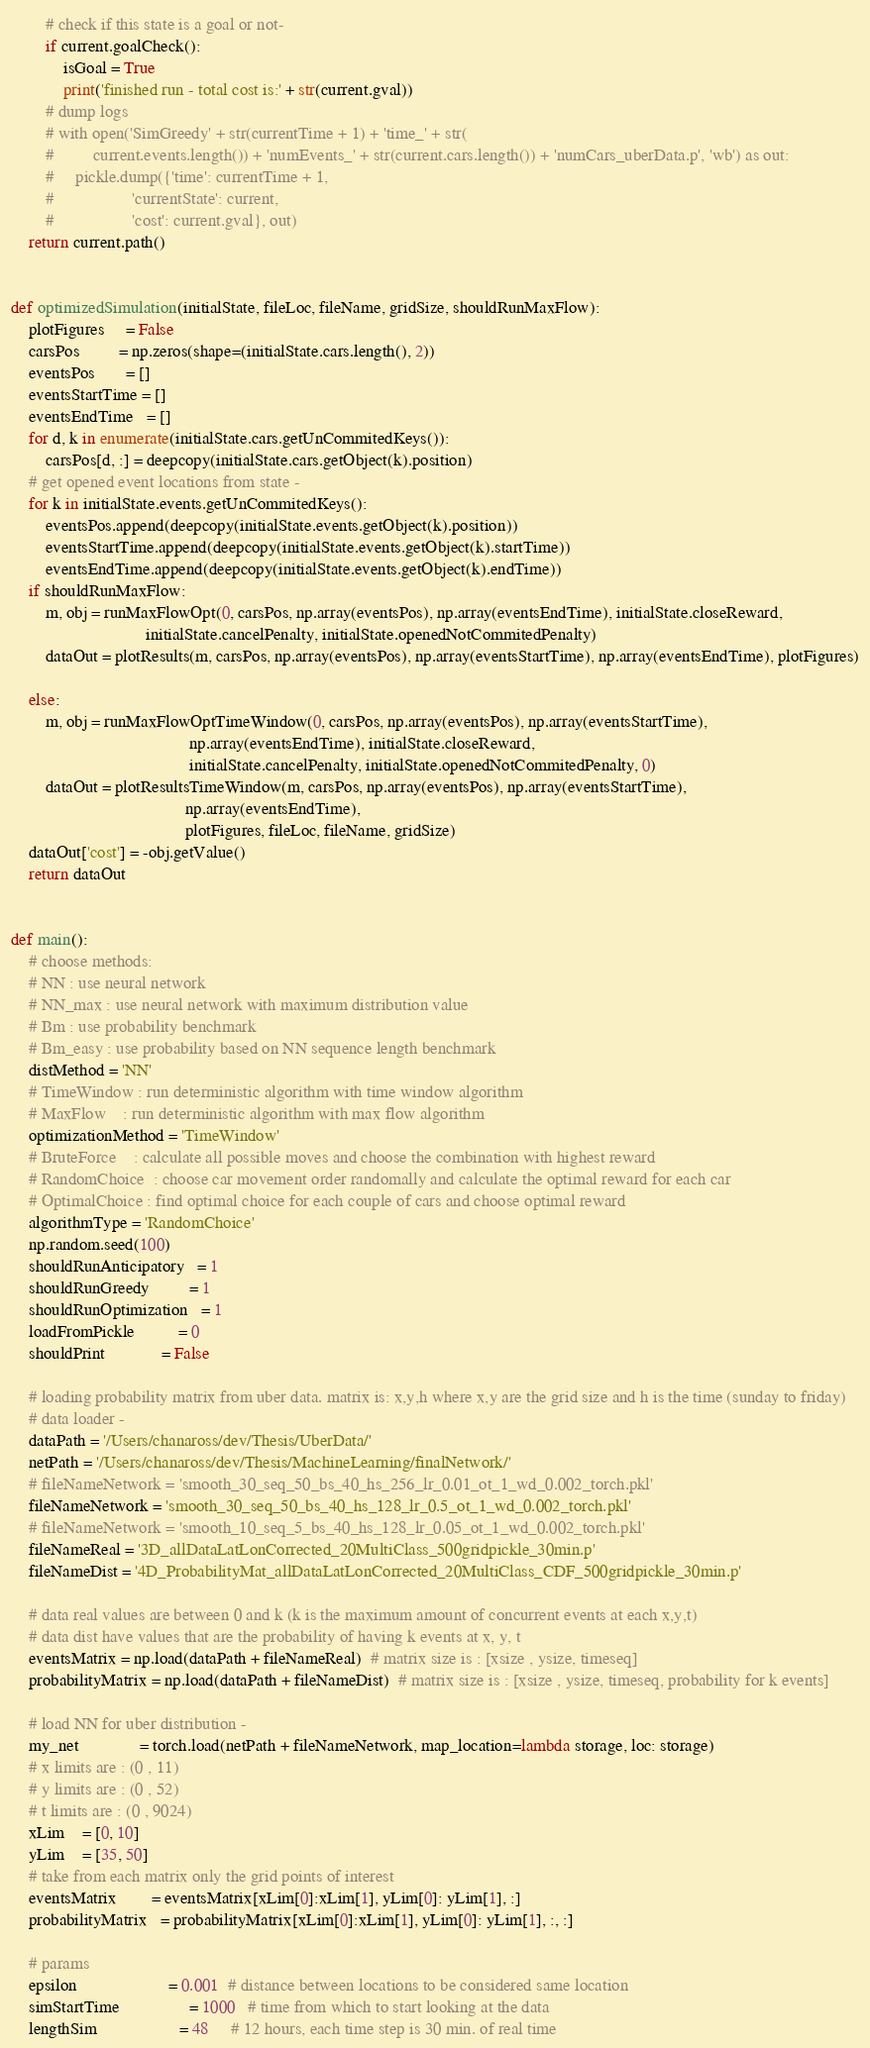Convert code to text. <code><loc_0><loc_0><loc_500><loc_500><_Python_>        # check if this state is a goal or not-
        if current.goalCheck():
            isGoal = True
            print('finished run - total cost is:' + str(current.gval))
        # dump logs
        # with open('SimGreedy' + str(currentTime + 1) + 'time_' + str(
        #         current.events.length()) + 'numEvents_' + str(current.cars.length()) + 'numCars_uberData.p', 'wb') as out:
        #     pickle.dump({'time': currentTime + 1,
        #                  'currentState': current,
        #                  'cost': current.gval}, out)
    return current.path()


def optimizedSimulation(initialState, fileLoc, fileName, gridSize, shouldRunMaxFlow):
    plotFigures     = False
    carsPos         = np.zeros(shape=(initialState.cars.length(), 2))
    eventsPos       = []
    eventsStartTime = []
    eventsEndTime   = []
    for d, k in enumerate(initialState.cars.getUnCommitedKeys()):
        carsPos[d, :] = deepcopy(initialState.cars.getObject(k).position)
    # get opened event locations from state -
    for k in initialState.events.getUnCommitedKeys():
        eventsPos.append(deepcopy(initialState.events.getObject(k).position))
        eventsStartTime.append(deepcopy(initialState.events.getObject(k).startTime))
        eventsEndTime.append(deepcopy(initialState.events.getObject(k).endTime))
    if shouldRunMaxFlow:
        m, obj = runMaxFlowOpt(0, carsPos, np.array(eventsPos), np.array(eventsEndTime), initialState.closeReward,
                               initialState.cancelPenalty, initialState.openedNotCommitedPenalty)
        dataOut = plotResults(m, carsPos, np.array(eventsPos), np.array(eventsStartTime), np.array(eventsEndTime), plotFigures)

    else:
        m, obj = runMaxFlowOptTimeWindow(0, carsPos, np.array(eventsPos), np.array(eventsStartTime),
                                         np.array(eventsEndTime), initialState.closeReward,
                                         initialState.cancelPenalty, initialState.openedNotCommitedPenalty, 0)
        dataOut = plotResultsTimeWindow(m, carsPos, np.array(eventsPos), np.array(eventsStartTime),
                                        np.array(eventsEndTime),
                                        plotFigures, fileLoc, fileName, gridSize)
    dataOut['cost'] = -obj.getValue()
    return dataOut


def main():
    # choose methods:
    # NN : use neural network
    # NN_max : use neural network with maximum distribution value
    # Bm : use probability benchmark
    # Bm_easy : use probability based on NN sequence length benchmark
    distMethod = 'NN'
    # TimeWindow : run deterministic algorithm with time window algorithm
    # MaxFlow    : run deterministic algorithm with max flow algorithm
    optimizationMethod = 'TimeWindow'
    # BruteForce    : calculate all possible moves and choose the combination with highest reward
    # RandomChoice  : choose car movement order randomally and calculate the optimal reward for each car
    # OptimalChoice : find optimal choice for each couple of cars and choose optimal reward
    algorithmType = 'RandomChoice'
    np.random.seed(100)
    shouldRunAnticipatory   = 1
    shouldRunGreedy         = 1
    shouldRunOptimization   = 1
    loadFromPickle          = 0
    shouldPrint             = False

    # loading probability matrix from uber data. matrix is: x,y,h where x,y are the grid size and h is the time (sunday to friday)
    # data loader -
    dataPath = '/Users/chanaross/dev/Thesis/UberData/'
    netPath = '/Users/chanaross/dev/Thesis/MachineLearning/finalNetwork/'
    # fileNameNetwork = 'smooth_30_seq_50_bs_40_hs_256_lr_0.01_ot_1_wd_0.002_torch.pkl'
    fileNameNetwork = 'smooth_30_seq_50_bs_40_hs_128_lr_0.5_ot_1_wd_0.002_torch.pkl'
    # fileNameNetwork = 'smooth_10_seq_5_bs_40_hs_128_lr_0.05_ot_1_wd_0.002_torch.pkl'
    fileNameReal = '3D_allDataLatLonCorrected_20MultiClass_500gridpickle_30min.p'
    fileNameDist = '4D_ProbabilityMat_allDataLatLonCorrected_20MultiClass_CDF_500gridpickle_30min.p'

    # data real values are between 0 and k (k is the maximum amount of concurrent events at each x,y,t)
    # data dist have values that are the probability of having k events at x, y, t
    eventsMatrix = np.load(dataPath + fileNameReal)  # matrix size is : [xsize , ysize, timeseq]
    probabilityMatrix = np.load(dataPath + fileNameDist)  # matrix size is : [xsize , ysize, timeseq, probability for k events]

    # load NN for uber distribution -
    my_net              = torch.load(netPath + fileNameNetwork, map_location=lambda storage, loc: storage)
    # x limits are : (0 , 11)
    # y limits are : (0 , 52)
    # t limits are : (0 , 9024)
    xLim    = [0, 10]
    yLim    = [35, 50]
    # take from each matrix only the grid points of interest
    eventsMatrix        = eventsMatrix[xLim[0]:xLim[1], yLim[0]: yLim[1], :]
    probabilityMatrix   = probabilityMatrix[xLim[0]:xLim[1], yLim[0]: yLim[1], :, :]

    # params
    epsilon                     = 0.001  # distance between locations to be considered same location
    simStartTime                = 1000   # time from which to start looking at the data
    lengthSim                   = 48     # 12 hours, each time step is 30 min. of real time</code> 